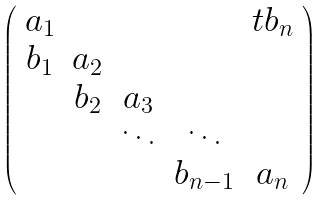<formula> <loc_0><loc_0><loc_500><loc_500>\left ( \begin{array} { c c c c c } a _ { 1 } & & & & t b _ { n } \\ b _ { 1 } & a _ { 2 } \\ & b _ { 2 } & a _ { 3 } \\ & & \ddots & \ddots \\ & & & b _ { n - 1 } & a _ { n } \end{array} \right )</formula> 